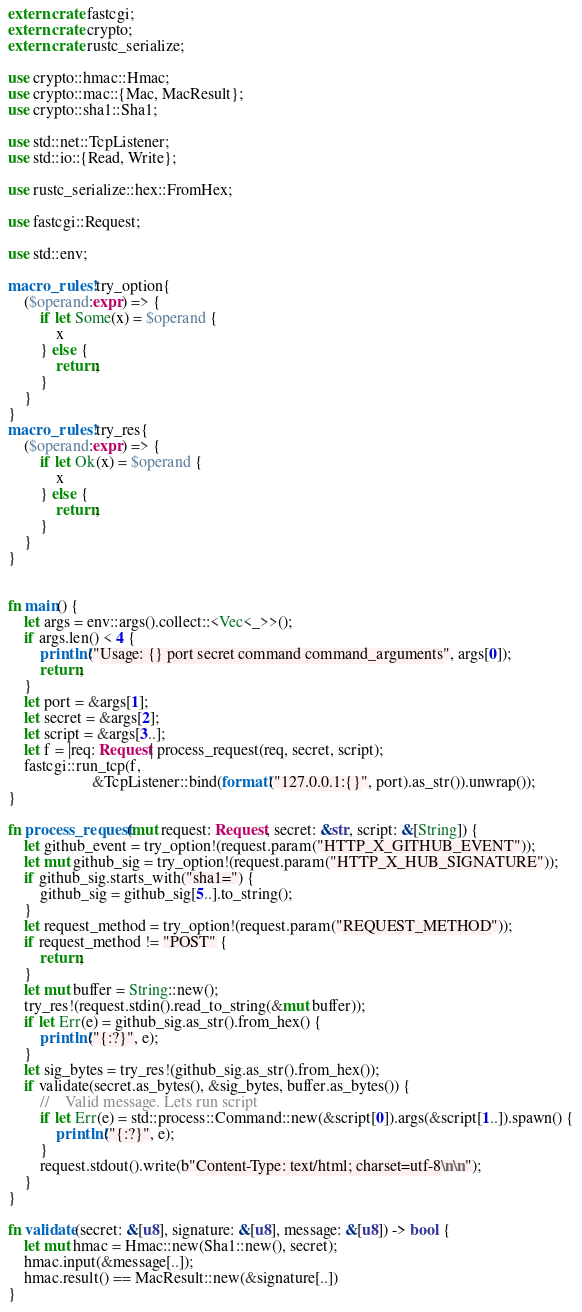Convert code to text. <code><loc_0><loc_0><loc_500><loc_500><_Rust_>extern crate fastcgi;
extern crate crypto;
extern crate rustc_serialize;

use crypto::hmac::Hmac;
use crypto::mac::{Mac, MacResult};
use crypto::sha1::Sha1;

use std::net::TcpListener;
use std::io::{Read, Write};

use rustc_serialize::hex::FromHex;

use fastcgi::Request;

use std::env;

macro_rules! try_option{
    ($operand:expr) => {
        if let Some(x) = $operand {
            x
        } else {
            return;
        }
    }
}
macro_rules! try_res{
    ($operand:expr) => {
        if let Ok(x) = $operand {
            x
        } else {
            return;
        }
    }
}


fn main() {
    let args = env::args().collect::<Vec<_>>();
    if args.len() < 4 {
        println!("Usage: {} port secret command command_arguments", args[0]);
        return;
    }
    let port = &args[1];
    let secret = &args[2];
    let script = &args[3..];
    let f = |req: Request| process_request(req, secret, script);
    fastcgi::run_tcp(f,
                     &TcpListener::bind(format!("127.0.0.1:{}", port).as_str()).unwrap());
}

fn process_request(mut request: Request, secret: &str, script: &[String]) {
    let github_event = try_option!(request.param("HTTP_X_GITHUB_EVENT"));
    let mut github_sig = try_option!(request.param("HTTP_X_HUB_SIGNATURE"));
    if github_sig.starts_with("sha1=") {
        github_sig = github_sig[5..].to_string();
    }
    let request_method = try_option!(request.param("REQUEST_METHOD"));
    if request_method != "POST" {
        return;
    }
    let mut buffer = String::new();
    try_res!(request.stdin().read_to_string(&mut buffer));
    if let Err(e) = github_sig.as_str().from_hex() {
        println!("{:?}", e);
    }
    let sig_bytes = try_res!(github_sig.as_str().from_hex());
    if validate(secret.as_bytes(), &sig_bytes, buffer.as_bytes()) {
        //    Valid message. Lets run script
        if let Err(e) = std::process::Command::new(&script[0]).args(&script[1..]).spawn() {
            println!("{:?}", e);
        }
        request.stdout().write(b"Content-Type: text/html; charset=utf-8\n\n");
    }
}

fn validate(secret: &[u8], signature: &[u8], message: &[u8]) -> bool {
    let mut hmac = Hmac::new(Sha1::new(), secret);
    hmac.input(&message[..]);
    hmac.result() == MacResult::new(&signature[..])
}
</code> 